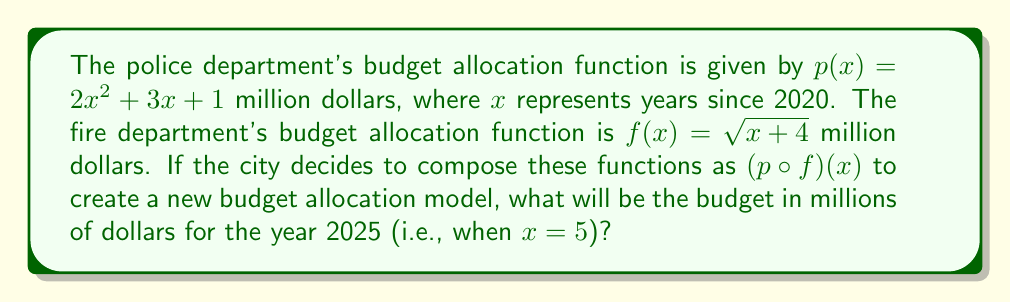Can you answer this question? Let's approach this step-by-step:

1) We need to find $(p \circ f)(5)$, which means we first calculate $f(5)$, then use that result as the input for $p$.

2) Calculate $f(5)$:
   $f(5) = \sqrt{5 + 4} = \sqrt{9} = 3$

3) Now we use this result as the input for $p$:
   $p(f(5)) = p(3)$

4) Calculate $p(3)$:
   $p(3) = 2(3)^2 + 3(3) + 1$
   
5) Simplify:
   $p(3) = 2(9) + 9 + 1$
   $p(3) = 18 + 9 + 1 = 28$

6) Therefore, $(p \circ f)(5) = 28$
Answer: $28$ million dollars 